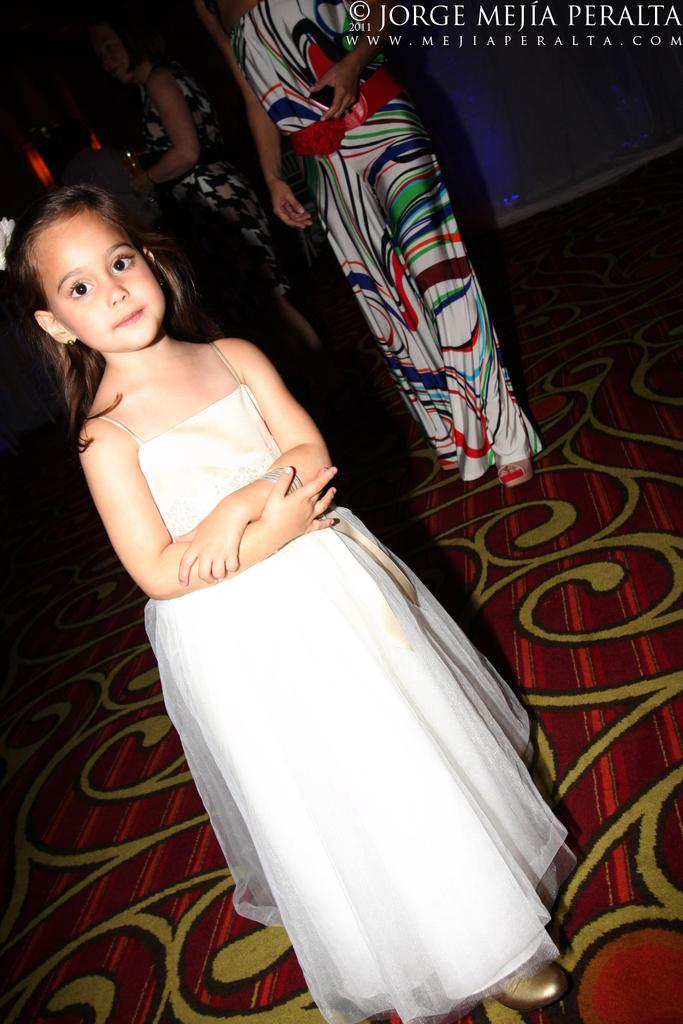What can be seen in the image? There is a group of people in the image. Can you describe the girl in the image? The girl is on the left side of the image and is wearing a white dress. Where are the watermarks located in the image? The watermarks are on the right top of the image. What type of vessel is being used by the group of people in the image? There is no vessel present in the image; it only shows a group of people and a girl. 